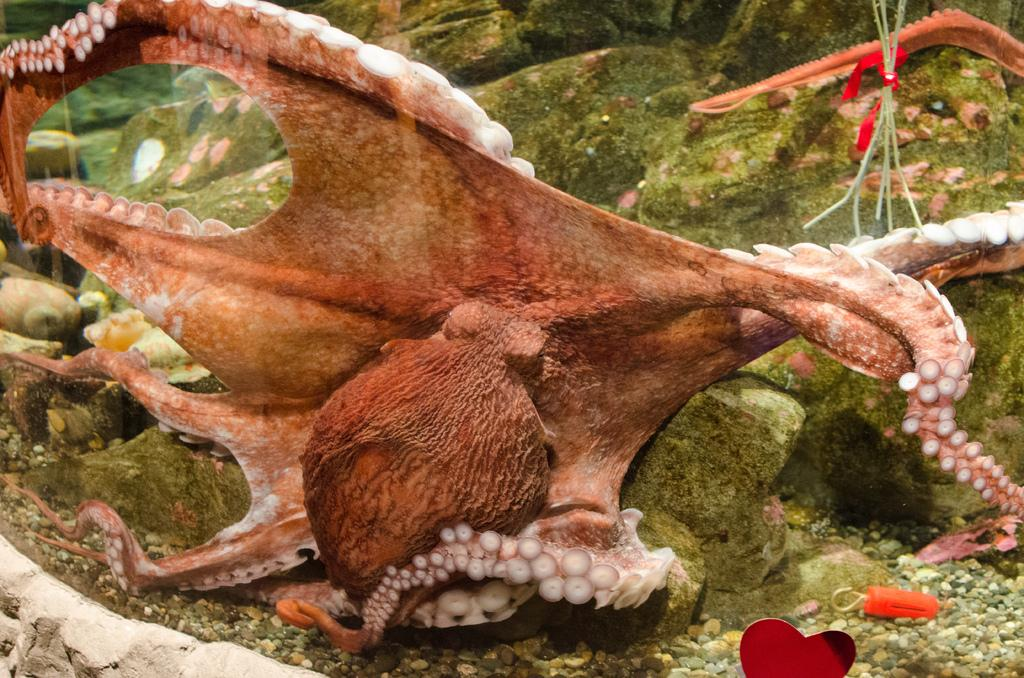What type of animal is in the picture? There is a common octopus in the picture. Where is the octopus located? The octopus is underwater. What else can be seen in the picture besides the octopus? There are stones visible in the picture. What type of oatmeal is being served on the plate in the picture? There is no plate or oatmeal present in the image; it features a common octopus underwater with stones visible. 